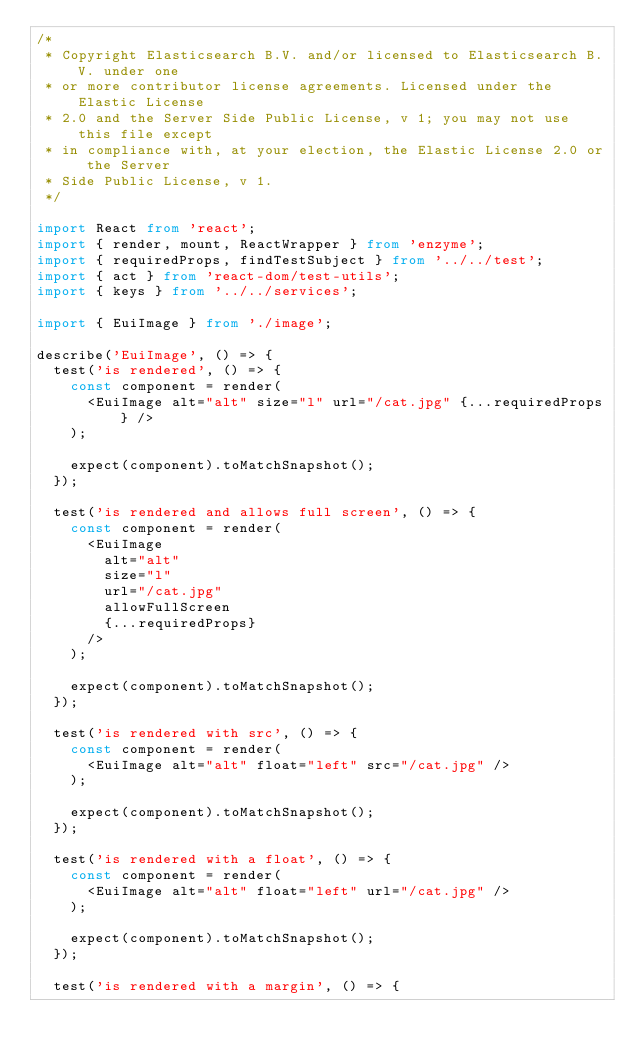Convert code to text. <code><loc_0><loc_0><loc_500><loc_500><_TypeScript_>/*
 * Copyright Elasticsearch B.V. and/or licensed to Elasticsearch B.V. under one
 * or more contributor license agreements. Licensed under the Elastic License
 * 2.0 and the Server Side Public License, v 1; you may not use this file except
 * in compliance with, at your election, the Elastic License 2.0 or the Server
 * Side Public License, v 1.
 */

import React from 'react';
import { render, mount, ReactWrapper } from 'enzyme';
import { requiredProps, findTestSubject } from '../../test';
import { act } from 'react-dom/test-utils';
import { keys } from '../../services';

import { EuiImage } from './image';

describe('EuiImage', () => {
  test('is rendered', () => {
    const component = render(
      <EuiImage alt="alt" size="l" url="/cat.jpg" {...requiredProps} />
    );

    expect(component).toMatchSnapshot();
  });

  test('is rendered and allows full screen', () => {
    const component = render(
      <EuiImage
        alt="alt"
        size="l"
        url="/cat.jpg"
        allowFullScreen
        {...requiredProps}
      />
    );

    expect(component).toMatchSnapshot();
  });

  test('is rendered with src', () => {
    const component = render(
      <EuiImage alt="alt" float="left" src="/cat.jpg" />
    );

    expect(component).toMatchSnapshot();
  });

  test('is rendered with a float', () => {
    const component = render(
      <EuiImage alt="alt" float="left" url="/cat.jpg" />
    );

    expect(component).toMatchSnapshot();
  });

  test('is rendered with a margin', () => {</code> 